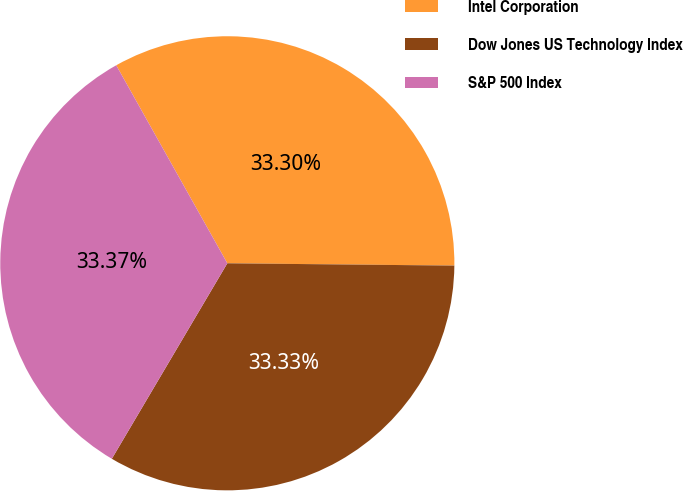Convert chart to OTSL. <chart><loc_0><loc_0><loc_500><loc_500><pie_chart><fcel>Intel Corporation<fcel>Dow Jones US Technology Index<fcel>S&P 500 Index<nl><fcel>33.3%<fcel>33.33%<fcel>33.37%<nl></chart> 